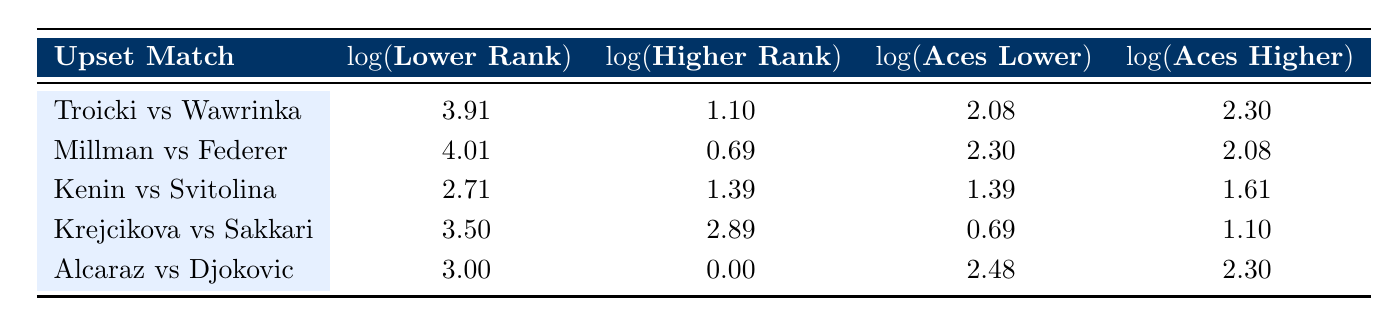What is the highest log value for the lower rank among the matches? Looking at the log values for the lower ranks in the table, the values are 3.91, 4.01, 2.71, 3.50, and 3.00. The highest value is 4.01, which corresponds to John Millman.
Answer: 4.01 Which match had the lowest log value for doubles faults by the lower-ranked player? The log values for double faults by the lower-ranked players are 1.39, 0.69, 0.00, 0.00, and 2.48. The lowest value is 0.00, which corresponds to both Barbora Krejcikova and Sofia Kenin.
Answer: 0.00 How many more aces did the lower-ranked players have on average compared to the higher-ranked players? For lower-ranked players, the aces are 8, 10, 4, 2, and 12, summing to 46. For higher-ranked players, the aces are 10, 8, 5, 3, and 10, summing to 36. The average for lower-ranked players is 46/5 = 9.2 and for higher-ranked players is 36/5 = 7.2. The difference is 9.2 - 7.2 = 2.
Answer: 2 Did any of the matches have the lower-ranked player with more aces than the higher-ranked player? Upon reviewing the matches, John Millman and Carlos Alcaraz had more aces (10 and 12, respectively) than their higher-ranked opponents (8 for Federer and 10 for Djokovic).
Answer: Yes Which match had the largest difference in log value between the lower-ranked player and the higher-ranked player? The differences in log values for each match are as follows: Troicki vs Wawrinka (3.91 - 1.10 = 2.81), Millman vs Federer (4.01 - 0.69 = 3.32), Kenin vs Svitolina (2.71 - 1.39 = 1.32), Krejcikova vs Sakkari (3.50 - 2.89 = 0.61), and Alcaraz vs Djokovic (3.00 - 0.00 = 3.00). The largest difference is 3.32 for Millman vs Federer.
Answer: 3.32 Which lower-ranked player had the highest log value for aces and what was the value? The log values for aces by lower-ranked players are 2.08, 2.30, 1.39, 0.69, and 2.48. The highest log value is 2.30, which corresponds to John Millman.
Answer: 2.30 